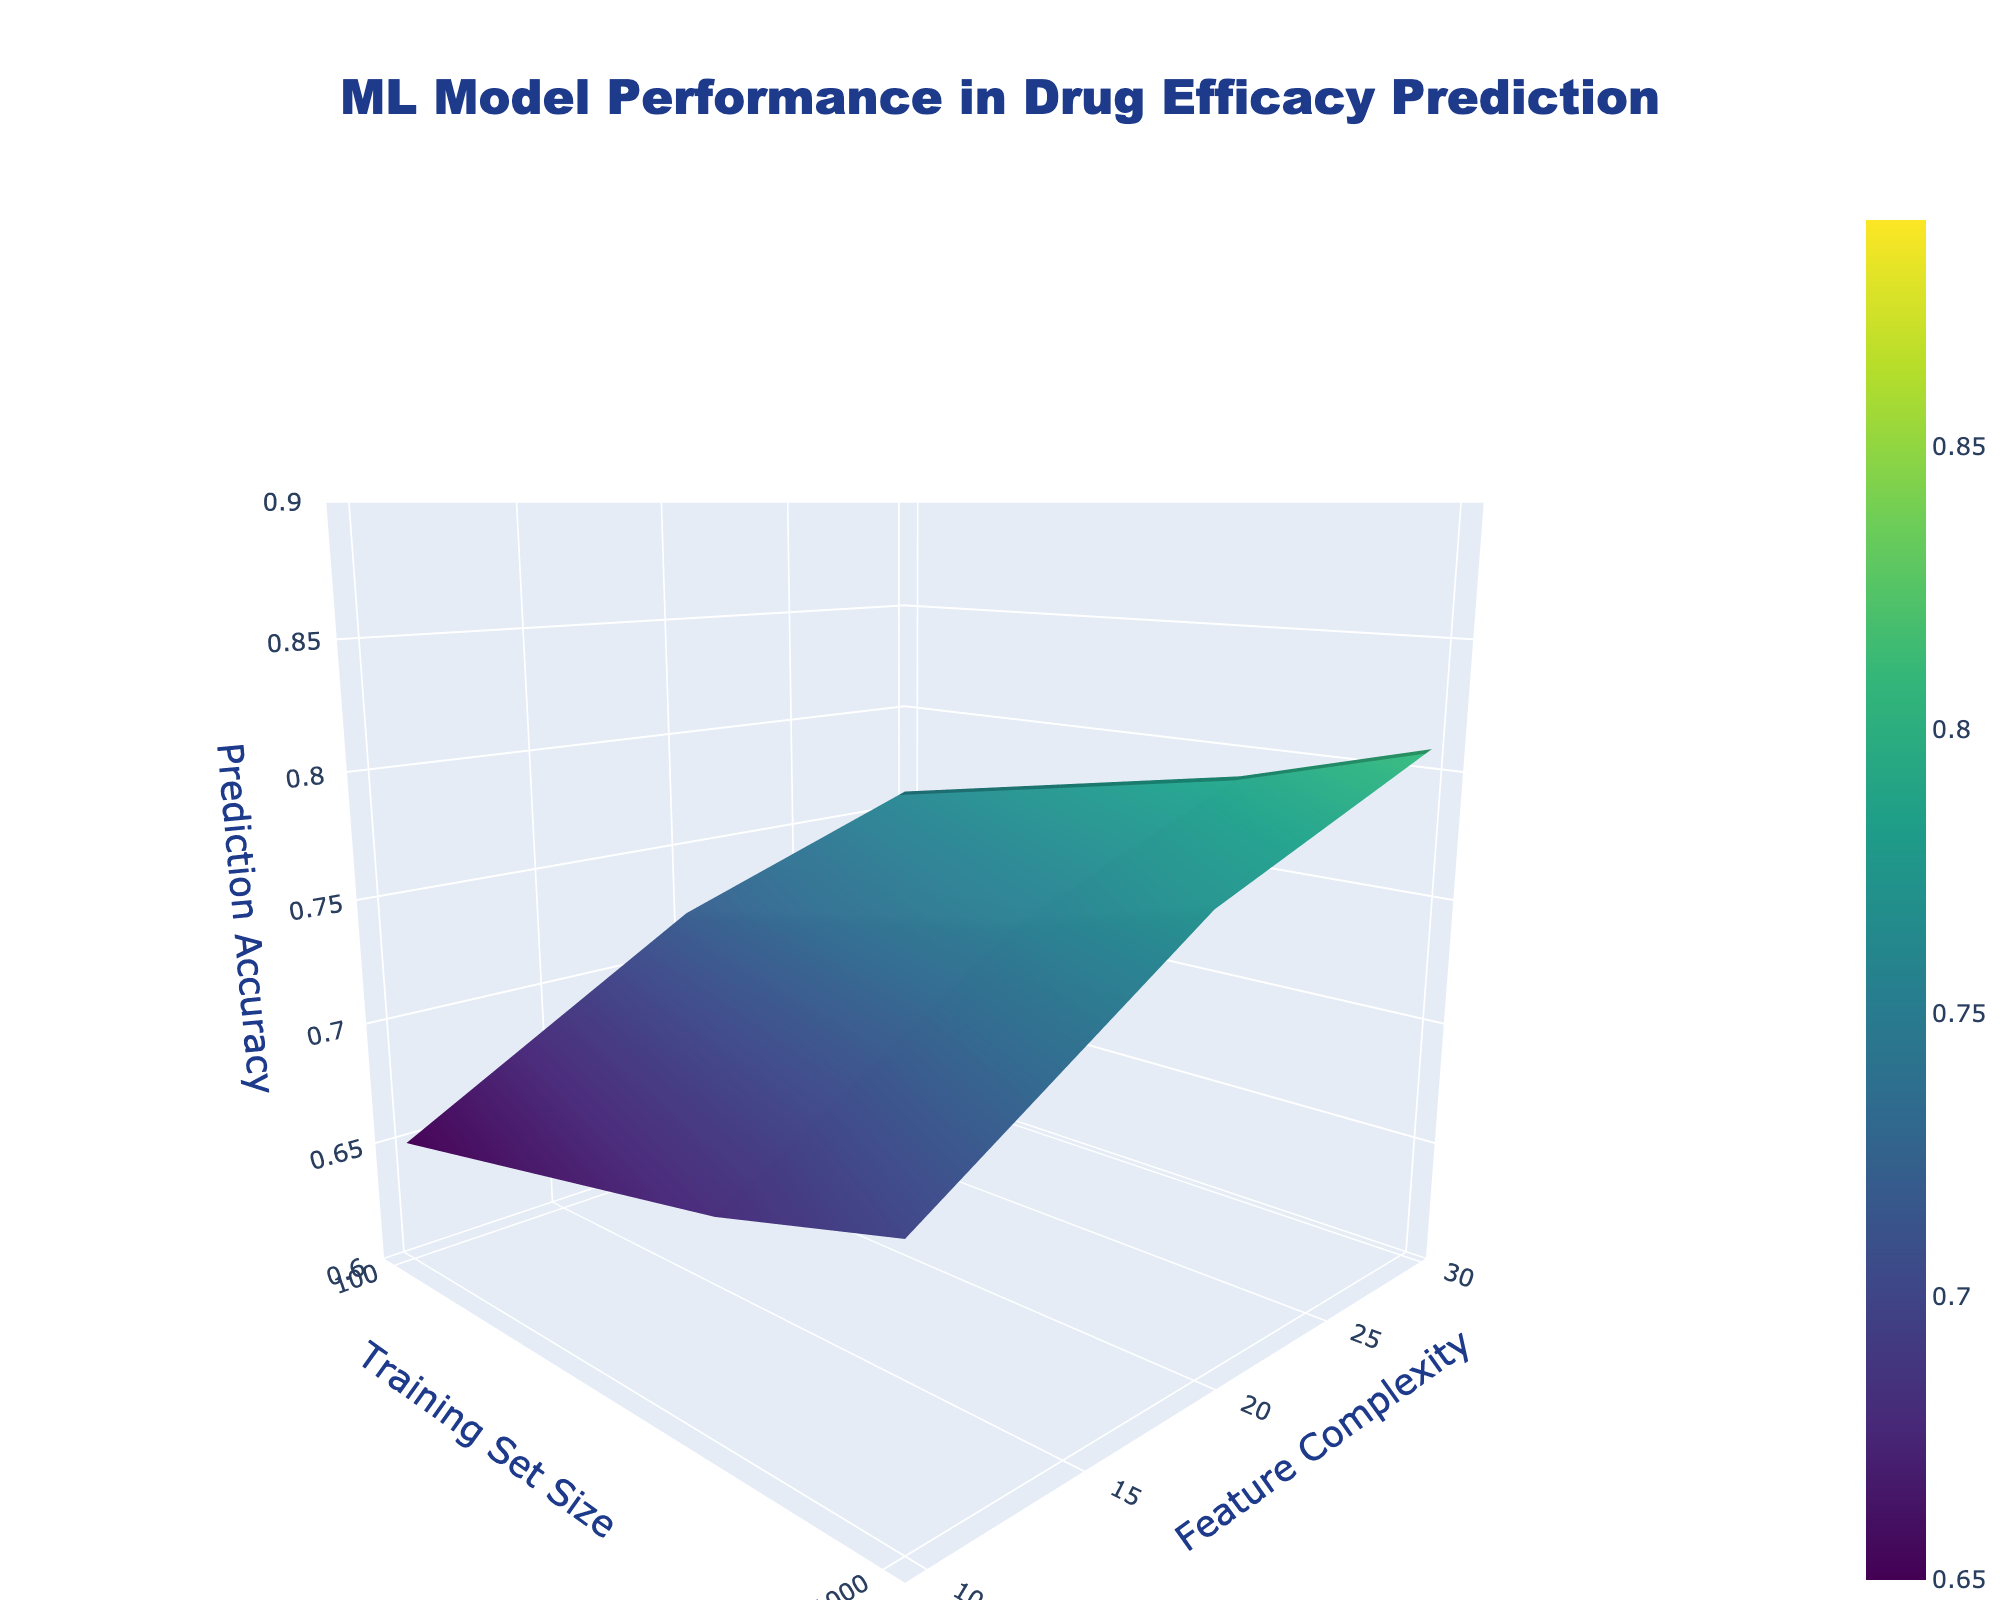What's the title of the 3D surface plot? The title of the 3D surface plot is at the top center of the figure. It reads 'ML Model Performance in Drug Efficacy Prediction'.
Answer: ML Model Performance in Drug Efficacy Prediction What's the range of the z-axis (Prediction Accuracy)? The range of the z-axis (Prediction Accuracy) is displayed along the vertical axis from the bottom to the top of the plot. It ranges from 0.6 to 0.9.
Answer: 0.6 to 0.9 Which training set size results in the highest prediction accuracy when the feature complexity is 30? To find the highest prediction accuracy for feature complexity 30, look along the y-axis at y=30 and scan vertically. The highest point for this y-value occurs at x=50000. The z-value (prediction accuracy) at this point is 0.89.
Answer: 50000 What is the effect of increasing the training set size from 1000 to 10000 on Prediction Accuracy when the feature complexity is 20? Find the prediction accuracy values at x=1000 and x=10000 for y=20 on the plot. At x=1000, the accuracy is 0.79, and at x=10000, the accuracy is 0.85. The increase is 0.85 - 0.79 = 0.06.
Answer: Increase by 0.06 Which training set size and feature complexity combination yields a prediction accuracy of approximately 0.87? Scan the surface plot for the z-value closest to 0.87. The combinations occur at (x=10000, y=30) and (x=50000, y=20).
Answer: (10000, 30) and (50000, 20) How does the prediction accuracy change as the feature complexity increases from 10 to 30 for a training set size of 5000? Analyze the z-values for the training set size of 5000 at y=10, y=20, and y=30. The accuracies are 0.80, 0.83, and 0.85 respectively. The change as feature complexity increases from 10 to 30 is 0.85 - 0.80 = 0.05.
Answer: Increase by 0.05 When the training set size is 500, what is the difference in prediction accuracy between the lowest and highest feature complexity values? Look at the prediction accuracies for x=500 at y=10 and y=30. The z-values are 0.72 (y=10) and 0.77 (y=30). The difference is 0.77 - 0.72 = 0.05.
Answer: 0.05 Is there a training set size where the prediction accuracy is constant across all feature complexity levels? Check each training set size to see if the z-values (prediction accuracies) are the same for all three feature complexity levels. None of the training set sizes exhibit constant prediction accuracy across different feature complexities.
Answer: No 